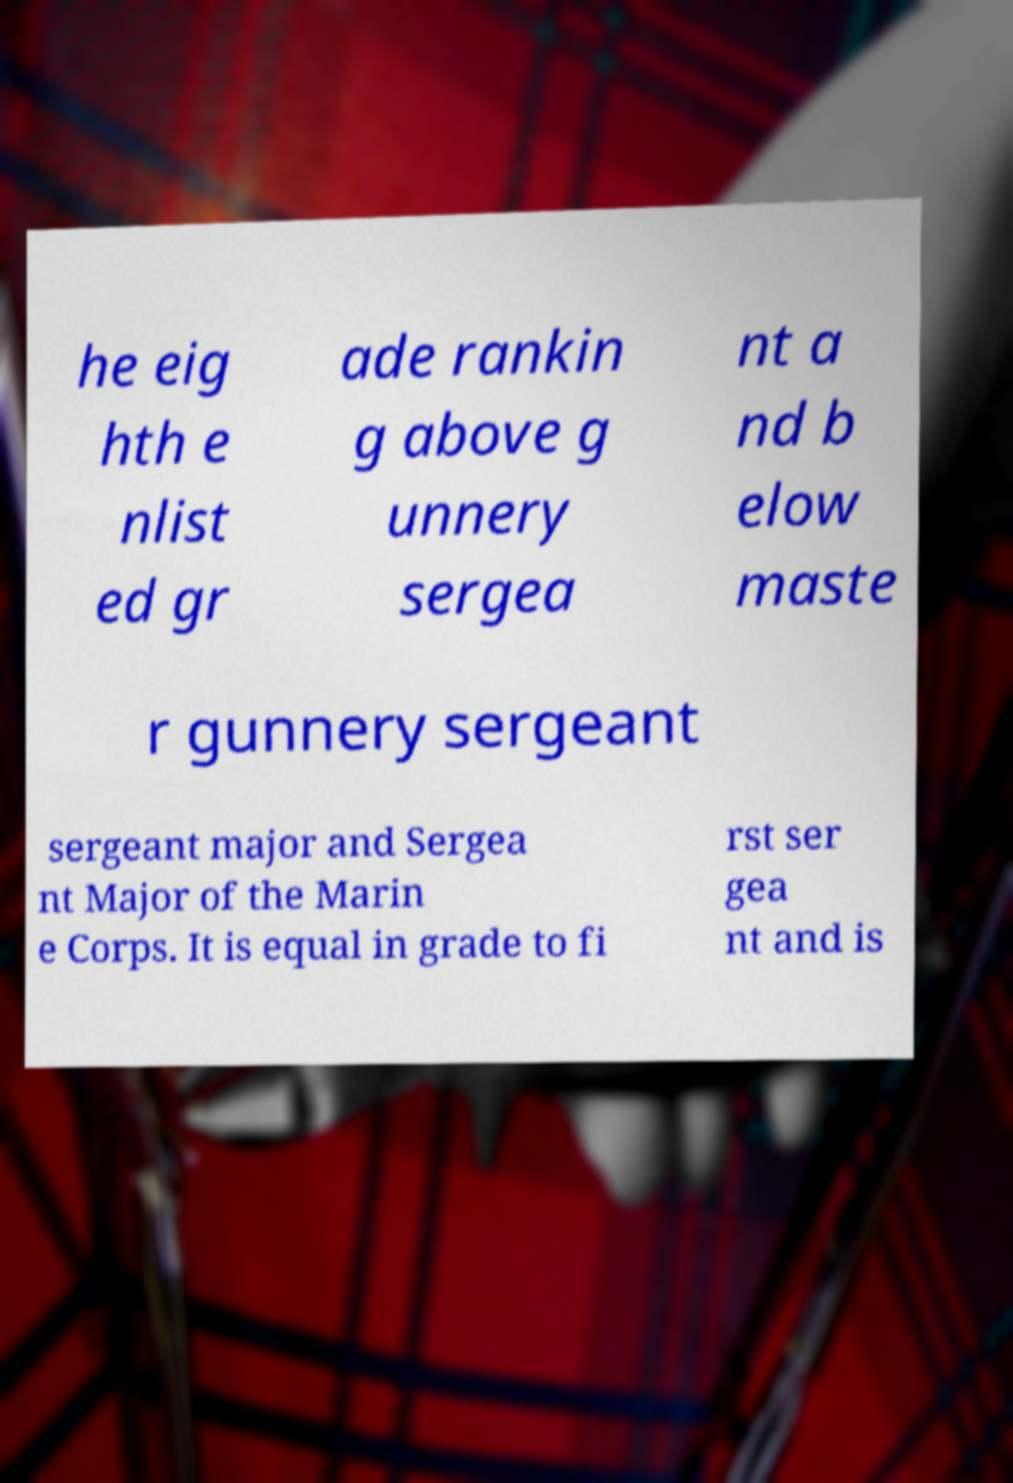I need the written content from this picture converted into text. Can you do that? he eig hth e nlist ed gr ade rankin g above g unnery sergea nt a nd b elow maste r gunnery sergeant sergeant major and Sergea nt Major of the Marin e Corps. It is equal in grade to fi rst ser gea nt and is 